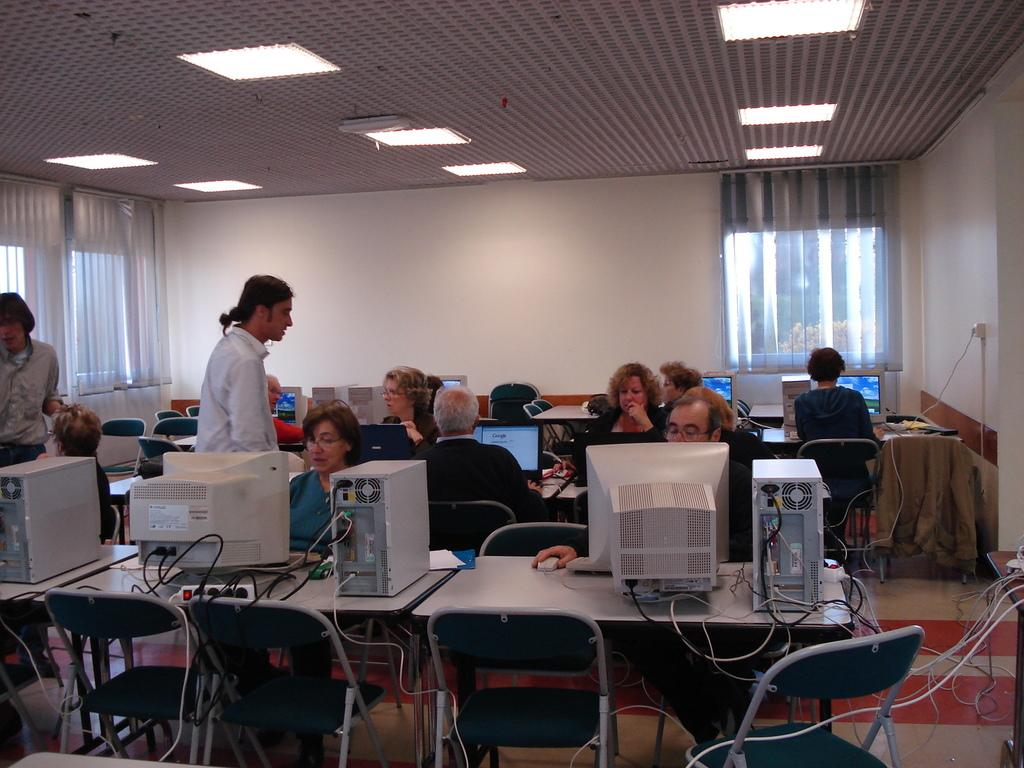What are the people in the image doing? The people in the image are sitting at desks and working with their systems. Can you describe the setting of the image? The setting is an office. What type of scent can be smelled coming from the people in the image? There is no indication of any scent in the image, as it features people working at desks in an office setting. What type of destruction can be seen in the image? There is no destruction present in the image; it shows people working in an office. 